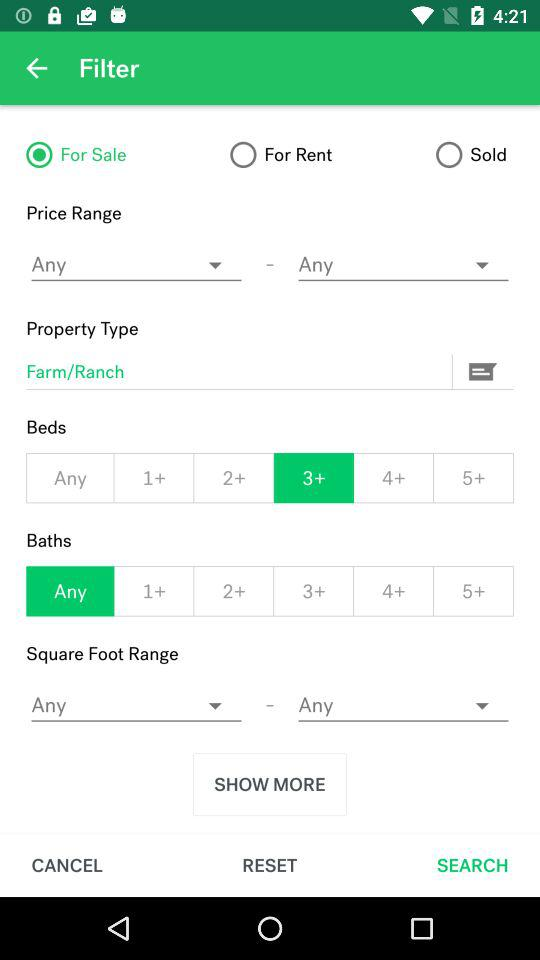Which option is selected in "Baths"? The selected option in "Baths" is "Any". 